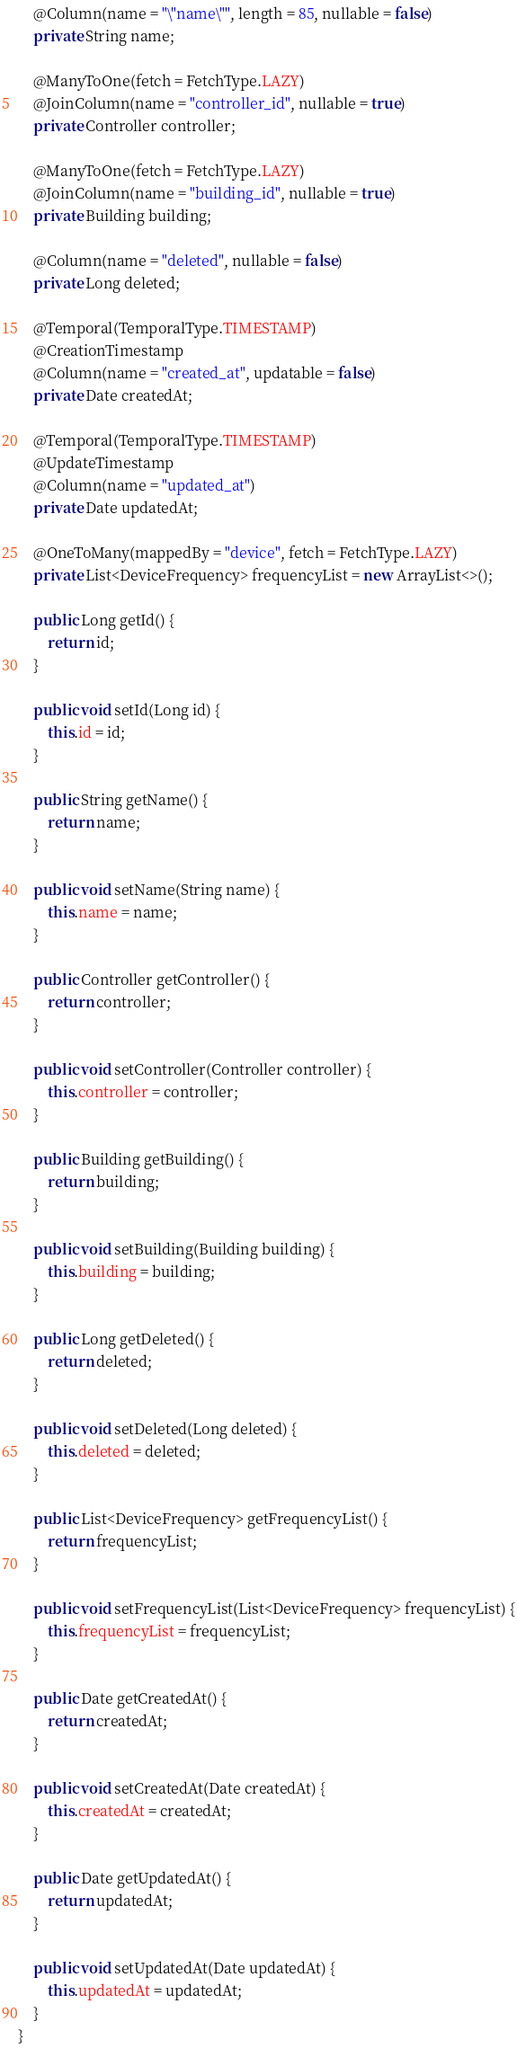<code> <loc_0><loc_0><loc_500><loc_500><_Java_>
    @Column(name = "\"name\"", length = 85, nullable = false)
    private String name;

    @ManyToOne(fetch = FetchType.LAZY)
    @JoinColumn(name = "controller_id", nullable = true)
    private Controller controller;

    @ManyToOne(fetch = FetchType.LAZY)
    @JoinColumn(name = "building_id", nullable = true)
    private Building building;

    @Column(name = "deleted", nullable = false)
    private Long deleted;

    @Temporal(TemporalType.TIMESTAMP)
    @CreationTimestamp
    @Column(name = "created_at", updatable = false)
    private Date createdAt;

    @Temporal(TemporalType.TIMESTAMP)
    @UpdateTimestamp
    @Column(name = "updated_at")
    private Date updatedAt;

    @OneToMany(mappedBy = "device", fetch = FetchType.LAZY)
    private List<DeviceFrequency> frequencyList = new ArrayList<>();

    public Long getId() {
        return id;
    }

    public void setId(Long id) {
        this.id = id;
    }

    public String getName() {
        return name;
    }

    public void setName(String name) {
        this.name = name;
    }

    public Controller getController() {
        return controller;
    }

    public void setController(Controller controller) {
        this.controller = controller;
    }

    public Building getBuilding() {
        return building;
    }

    public void setBuilding(Building building) {
        this.building = building;
    }

    public Long getDeleted() {
        return deleted;
    }

    public void setDeleted(Long deleted) {
        this.deleted = deleted;
    }

    public List<DeviceFrequency> getFrequencyList() {
        return frequencyList;
    }

    public void setFrequencyList(List<DeviceFrequency> frequencyList) {
        this.frequencyList = frequencyList;
    }

    public Date getCreatedAt() {
        return createdAt;
    }

    public void setCreatedAt(Date createdAt) {
        this.createdAt = createdAt;
    }

    public Date getUpdatedAt() {
        return updatedAt;
    }

    public void setUpdatedAt(Date updatedAt) {
        this.updatedAt = updatedAt;
    }
}</code> 